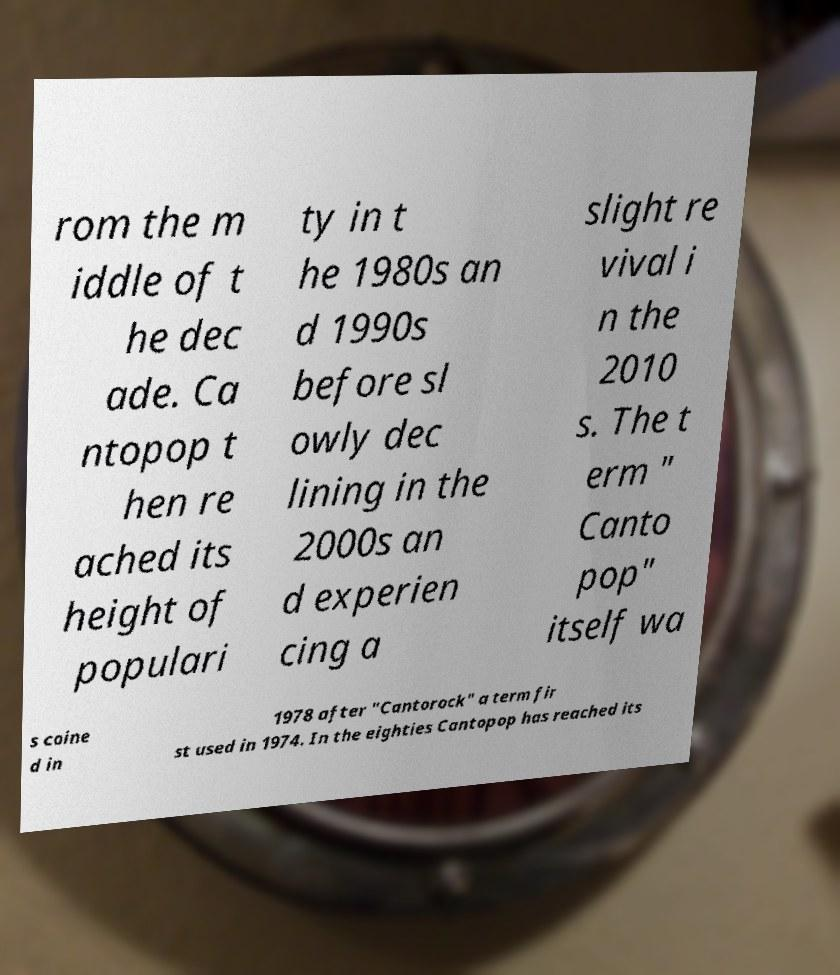Could you extract and type out the text from this image? rom the m iddle of t he dec ade. Ca ntopop t hen re ached its height of populari ty in t he 1980s an d 1990s before sl owly dec lining in the 2000s an d experien cing a slight re vival i n the 2010 s. The t erm " Canto pop" itself wa s coine d in 1978 after "Cantorock" a term fir st used in 1974. In the eighties Cantopop has reached its 